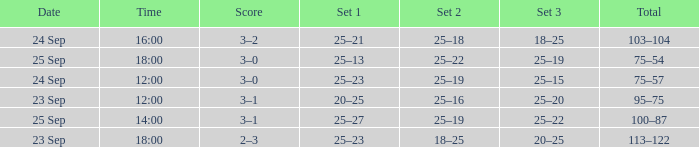What was the score when the time was 14:00? 3–1. 